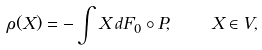<formula> <loc_0><loc_0><loc_500><loc_500>\rho ( X ) = - \int X \, d F _ { 0 } \circ P , \quad X \in V ,</formula> 